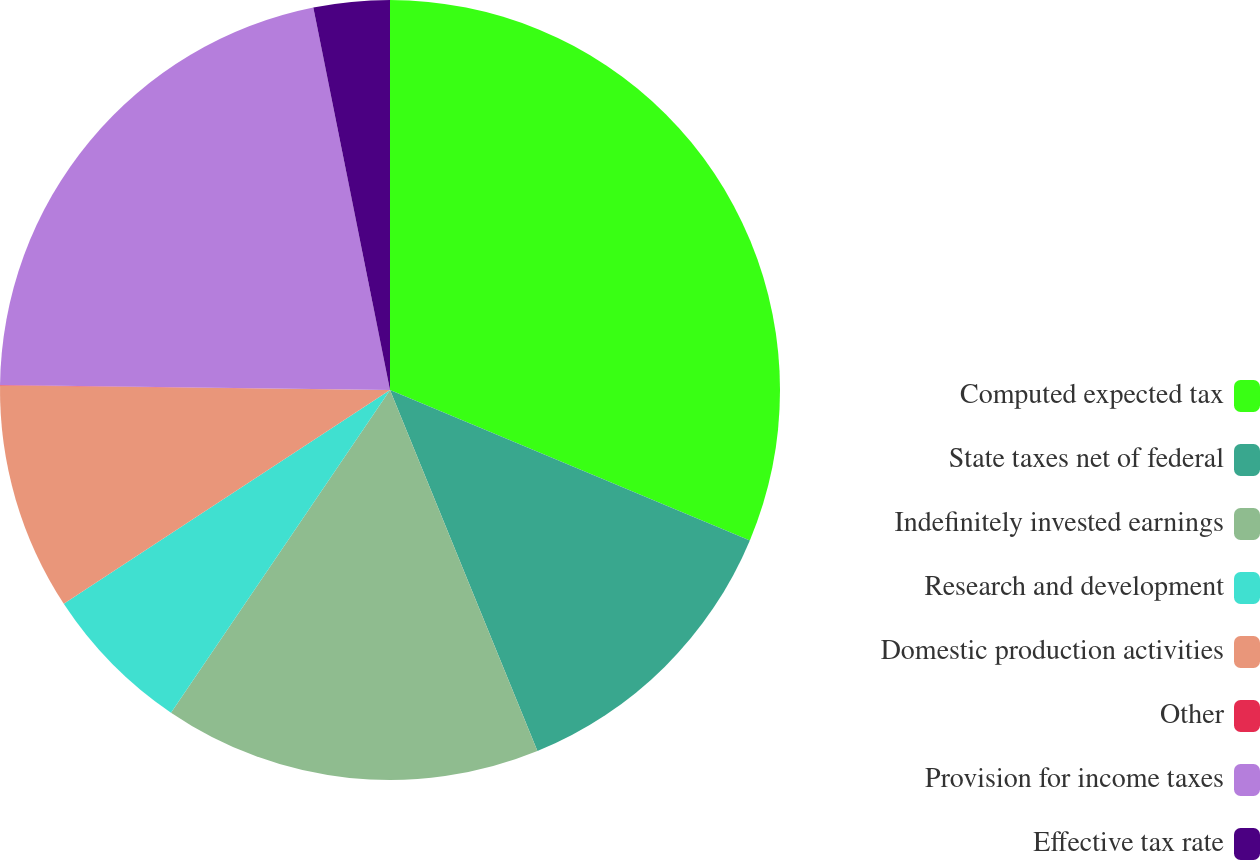<chart> <loc_0><loc_0><loc_500><loc_500><pie_chart><fcel>Computed expected tax<fcel>State taxes net of federal<fcel>Indefinitely invested earnings<fcel>Research and development<fcel>Domestic production activities<fcel>Other<fcel>Provision for income taxes<fcel>Effective tax rate<nl><fcel>31.3%<fcel>12.53%<fcel>15.66%<fcel>6.28%<fcel>9.41%<fcel>0.02%<fcel>21.65%<fcel>3.15%<nl></chart> 